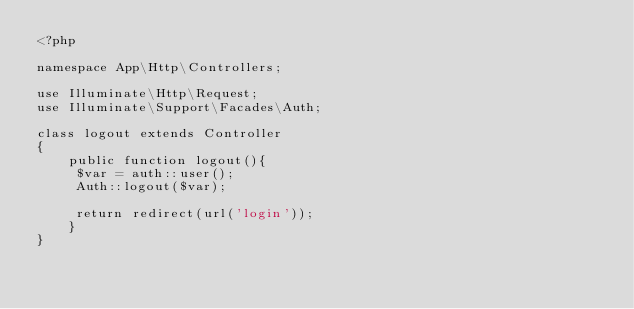<code> <loc_0><loc_0><loc_500><loc_500><_PHP_><?php

namespace App\Http\Controllers;

use Illuminate\Http\Request;
use Illuminate\Support\Facades\Auth;

class logout extends Controller
{
    public function logout(){
     $var = auth::user();
     Auth::logout($var);

     return redirect(url('login'));
    }
}
</code> 